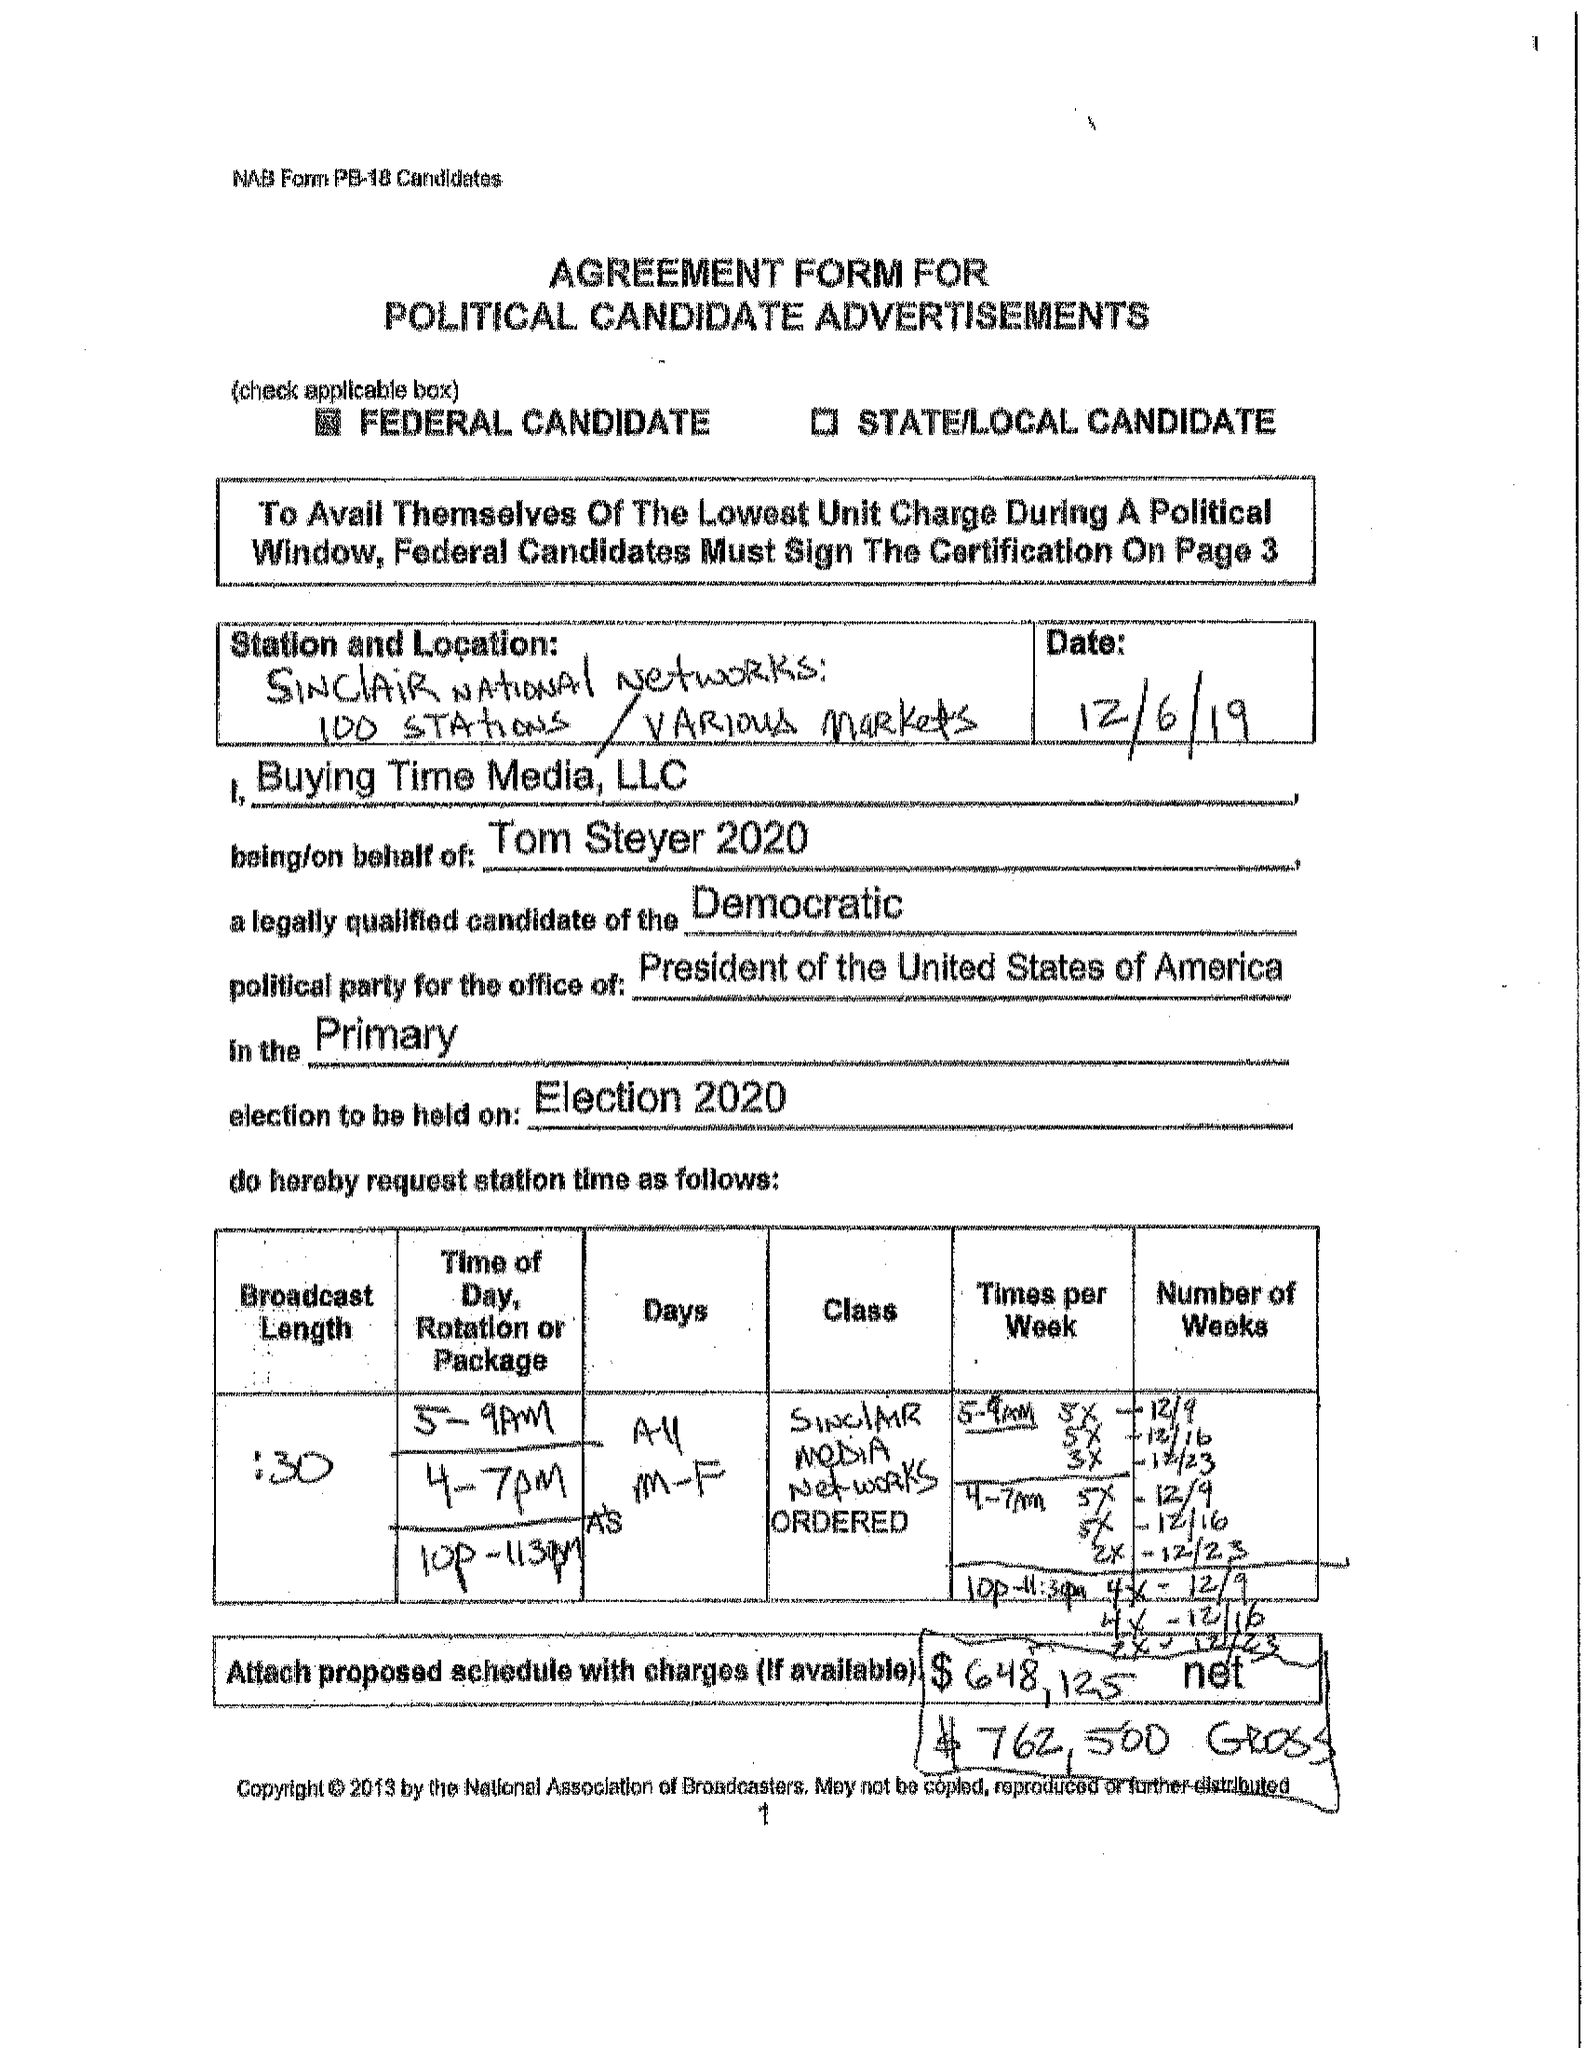What is the value for the contract_num?
Answer the question using a single word or phrase. None 